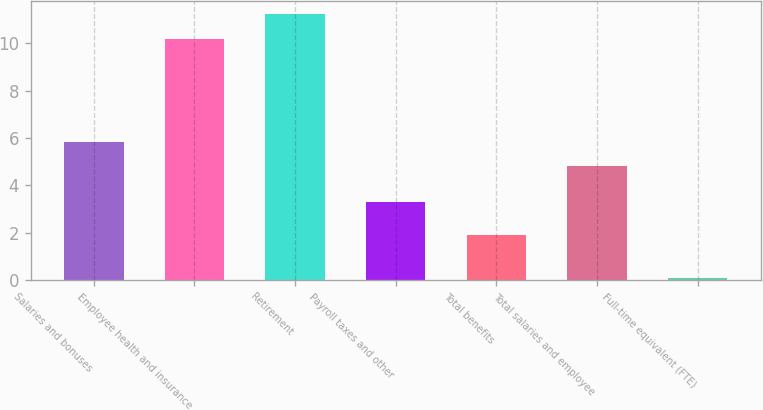Convert chart to OTSL. <chart><loc_0><loc_0><loc_500><loc_500><bar_chart><fcel>Salaries and bonuses<fcel>Employee health and insurance<fcel>Retirement<fcel>Payroll taxes and other<fcel>Total benefits<fcel>Total salaries and employee<fcel>Full-time equivalent (FTE)<nl><fcel>5.82<fcel>10.2<fcel>11.22<fcel>3.3<fcel>1.9<fcel>4.8<fcel>0.1<nl></chart> 